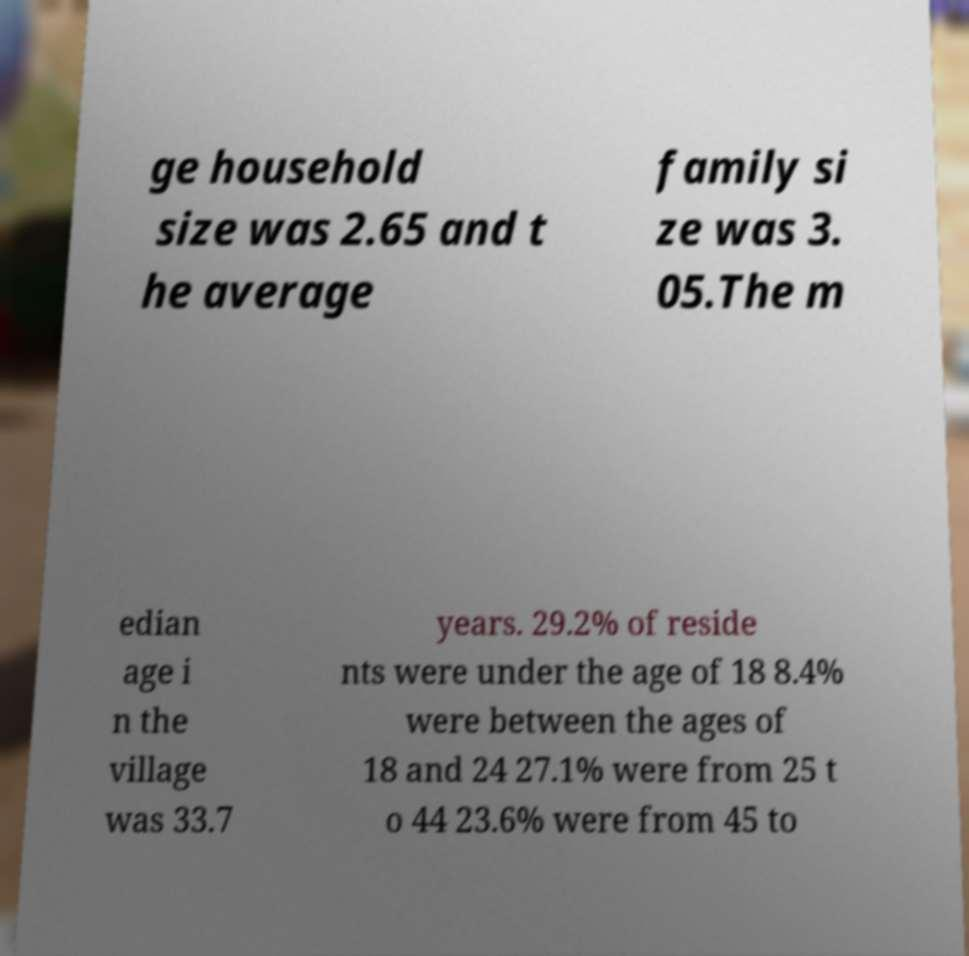Can you read and provide the text displayed in the image?This photo seems to have some interesting text. Can you extract and type it out for me? ge household size was 2.65 and t he average family si ze was 3. 05.The m edian age i n the village was 33.7 years. 29.2% of reside nts were under the age of 18 8.4% were between the ages of 18 and 24 27.1% were from 25 t o 44 23.6% were from 45 to 